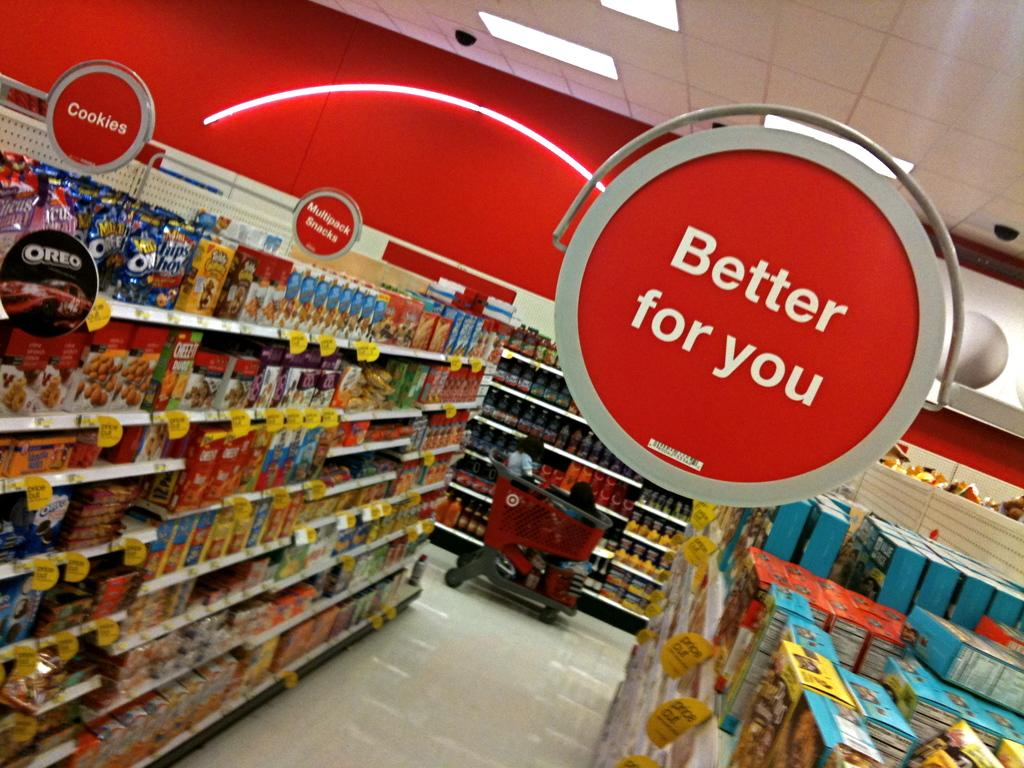<image>
Provide a brief description of the given image. The Target aisles have signs over them indicating the places for cookies, multipack snacks, and healthier food. 